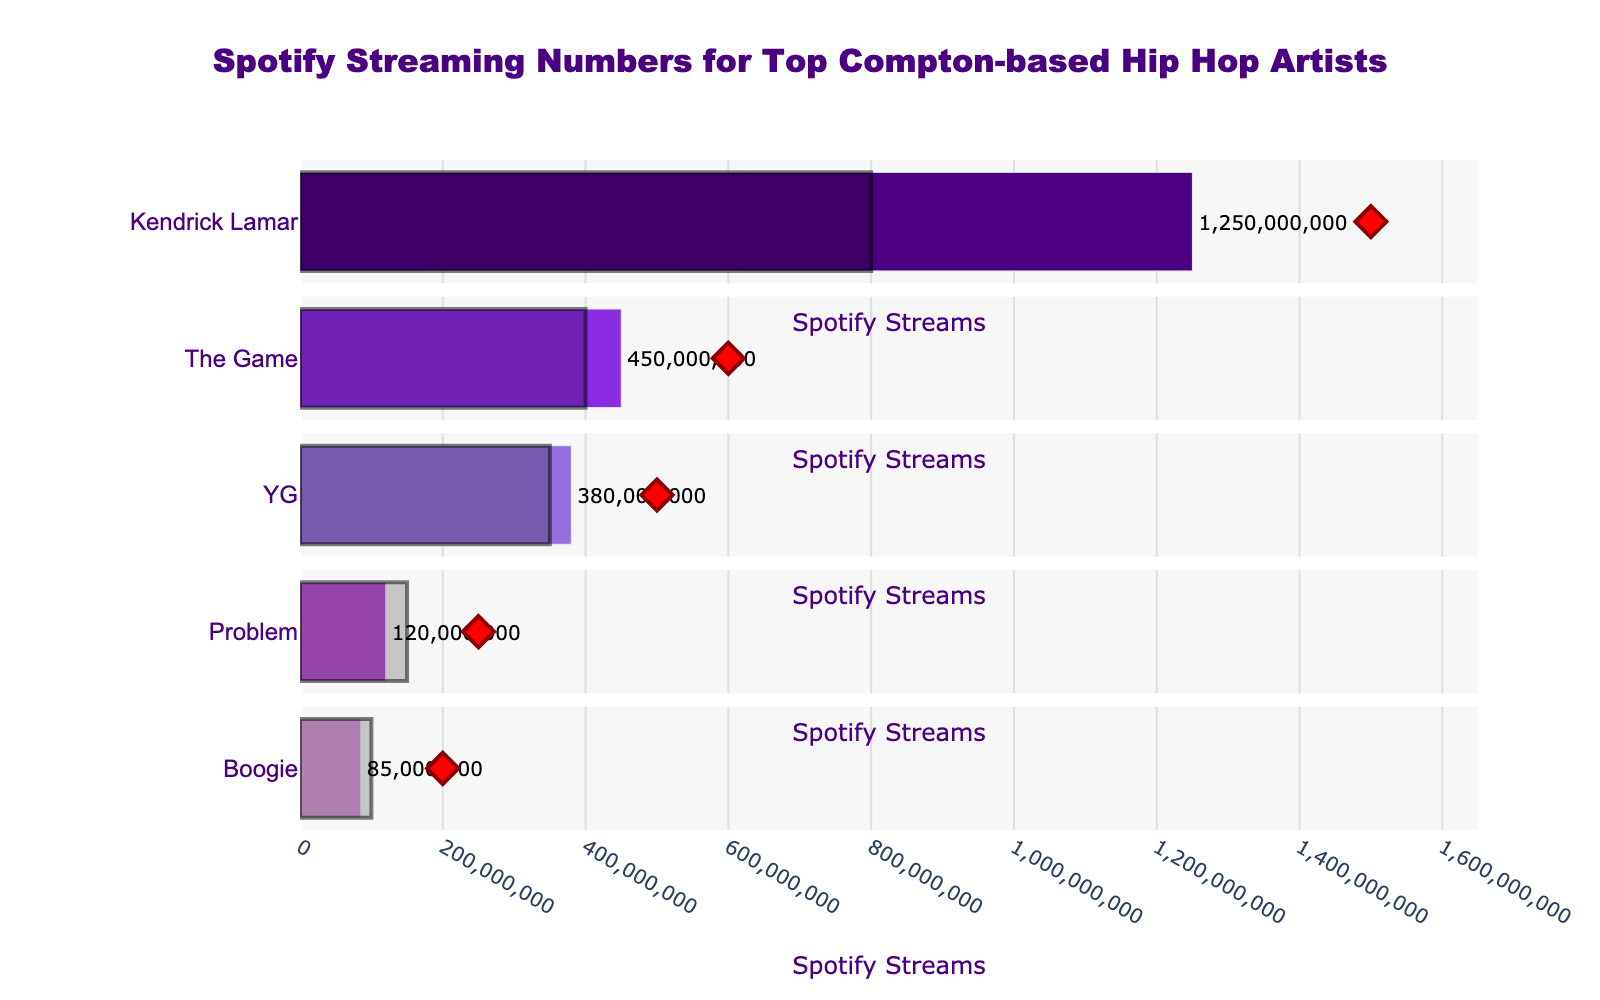What is the title of the figure? The title is displayed at the top of the figure. It reads, "Spotify Streaming Numbers for Top Compton-based Hip Hop Artists."
Answer: Spotify Streaming Numbers for Top Compton-based Hip Hop Artists Which artist has the highest actual streaming numbers? According to the bar lengths, Kendrick Lamar has the highest actual streaming numbers.
Answer: Kendrick Lamar How does YG's actual streaming numbers compare to the benchmark? The actual streaming number for YG is 380,000,000, while the benchmark is 350,000,000, so YG exceeded the benchmark by 30,000,000.
Answer: 30,000,000 What is the target streaming number for Boogie? The target number for Boogie can be seen from the red diamond marker in Boogie's row, indicated to be 200,000,000.
Answer: 200,000,000 Which artist missed their target by the largest amount? By comparing the positions of the actual (bar) and target (diamond marker) values, Problem missed the target by the largest amount. The target was 250,000,000, but the actual was only 120,000,000, so the difference is 130,000,000.
Answer: Problem What is the difference between Kendrick Lamar's actual streaming numbers and his target? Kendrick Lamar's actual streaming numbers are 1,250,000,000 and his target is 1,500,000,000. The difference is 1,500,000,000 - 1,250,000,000 = 250,000,000.
Answer: 250,000,000 Which artist is the closest to their target? Comparing the actual and target values, The Game comes closest to his target. His actual is 450,000,000 and his target is 600,000,000 which is a difference of 150,000,000. The differences for the other artists are larger.
Answer: The Game How many artists have actual streaming numbers above their industry's benchmark? By comparing actual streaming numbers (bar lengths) to the benchmark (gray bars), we see that Kendrick Lamar, The Game, and YG have streaming numbers above their benchmark. Thus, three artists exceed the benchmark.
Answer: 3 What is the average actual streaming number of all the listed artists? Sum the actual streaming numbers and divide by the number of artists. (1,250,000,000 + 450,000,000 + 380,000,000 + 120,000,000 + 85,000,000) / 5 = 2,285,000,000 / 5 = 457,000,000.
Answer: 457,000,000 